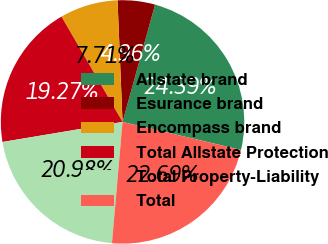Convert chart. <chart><loc_0><loc_0><loc_500><loc_500><pie_chart><fcel>Allstate brand<fcel>Esurance brand<fcel>Encompass brand<fcel>Total Allstate Protection<fcel>Total Property-Liability<fcel>Total<nl><fcel>24.39%<fcel>4.96%<fcel>7.71%<fcel>19.27%<fcel>20.98%<fcel>22.69%<nl></chart> 